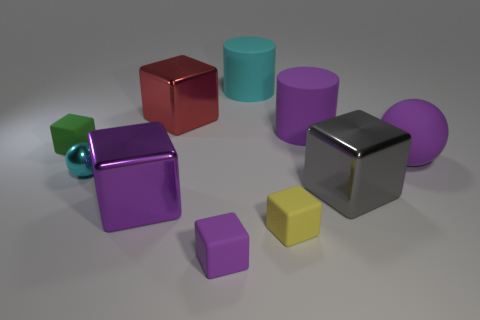Subtract all purple blocks. How many were subtracted if there are1purple blocks left? 1 Subtract all yellow cubes. How many cubes are left? 5 Subtract all big purple cubes. How many cubes are left? 5 Subtract all blue blocks. Subtract all green balls. How many blocks are left? 6 Subtract all cubes. How many objects are left? 4 Add 6 purple cubes. How many purple cubes are left? 8 Add 6 gray rubber balls. How many gray rubber balls exist? 6 Subtract 2 purple cubes. How many objects are left? 8 Subtract all small brown metallic cylinders. Subtract all small green rubber blocks. How many objects are left? 9 